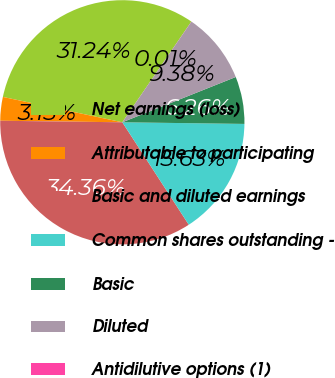Convert chart to OTSL. <chart><loc_0><loc_0><loc_500><loc_500><pie_chart><fcel>Net earnings (loss)<fcel>Attributable to participating<fcel>Basic and diluted earnings<fcel>Common shares outstanding -<fcel>Basic<fcel>Diluted<fcel>Antidilutive options (1)<nl><fcel>31.24%<fcel>3.13%<fcel>34.36%<fcel>15.63%<fcel>6.26%<fcel>9.38%<fcel>0.01%<nl></chart> 